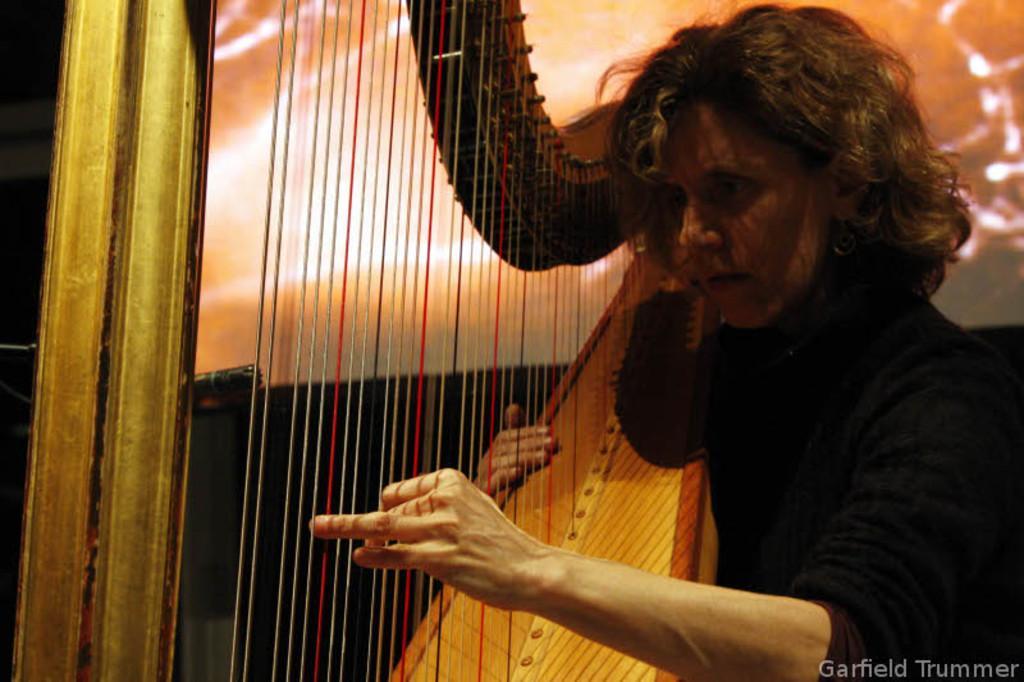Describe this image in one or two sentences. In this image we can see a woman holding musical instrument in the hands. 